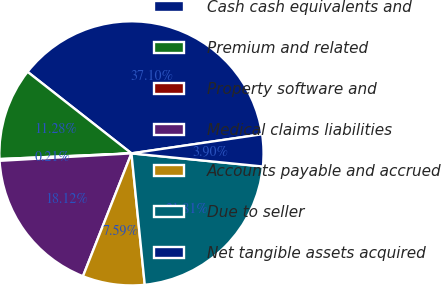<chart> <loc_0><loc_0><loc_500><loc_500><pie_chart><fcel>Cash cash equivalents and<fcel>Premium and related<fcel>Property software and<fcel>Medical claims liabilities<fcel>Accounts payable and accrued<fcel>Due to seller<fcel>Net tangible assets acquired<nl><fcel>37.1%<fcel>11.28%<fcel>0.21%<fcel>18.12%<fcel>7.59%<fcel>21.81%<fcel>3.9%<nl></chart> 